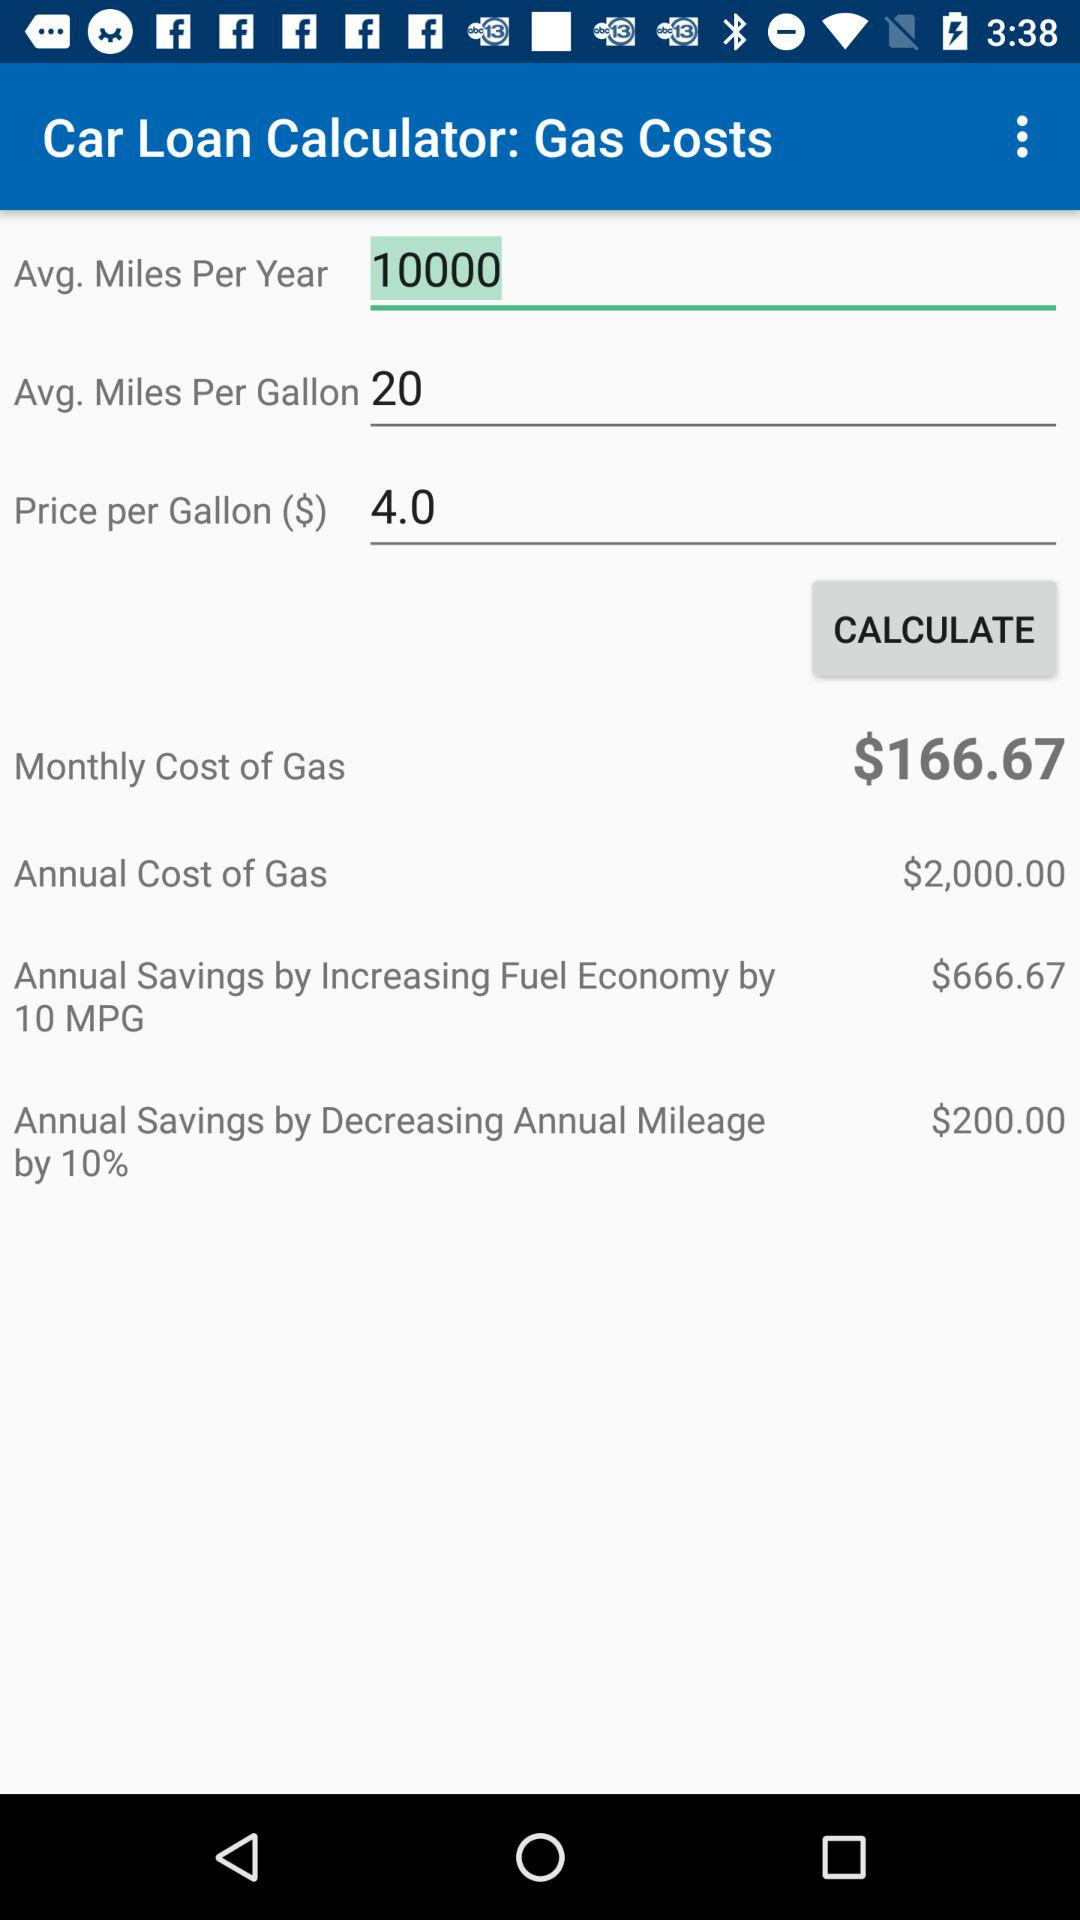How much does gas cost on an annual basis? The cost is $2,000 on an annual basis. 